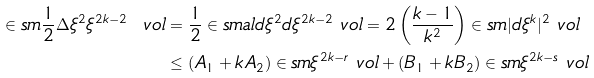<formula> <loc_0><loc_0><loc_500><loc_500>\in s m \frac { 1 } { 2 } \Delta \xi ^ { 2 } \xi ^ { 2 k - 2 } \ v o l & = \frac { 1 } { 2 } \in s m a l { d \xi ^ { 2 } } { d \xi ^ { 2 k - 2 } } \ v o l = 2 \left ( \frac { k - 1 } { k ^ { 2 } } \right ) \in s m | d \xi ^ { k } | ^ { 2 } \ v o l \\ & \leq ( A _ { 1 } + k A _ { 2 } ) \in s m \xi ^ { 2 k - r } \ v o l + ( B _ { 1 } + k B _ { 2 } ) \in s m \xi ^ { 2 k - s } \ v o l</formula> 